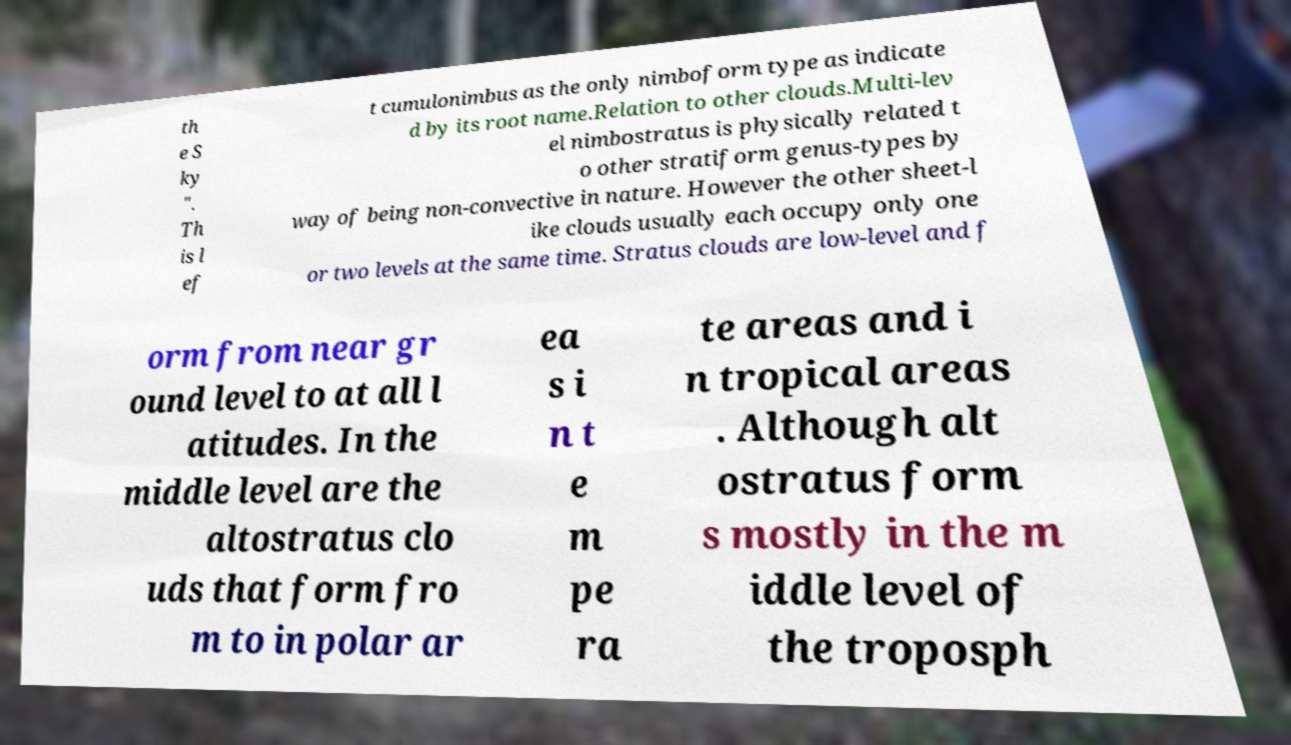Please identify and transcribe the text found in this image. th e S ky ". Th is l ef t cumulonimbus as the only nimboform type as indicate d by its root name.Relation to other clouds.Multi-lev el nimbostratus is physically related t o other stratiform genus-types by way of being non-convective in nature. However the other sheet-l ike clouds usually each occupy only one or two levels at the same time. Stratus clouds are low-level and f orm from near gr ound level to at all l atitudes. In the middle level are the altostratus clo uds that form fro m to in polar ar ea s i n t e m pe ra te areas and i n tropical areas . Although alt ostratus form s mostly in the m iddle level of the troposph 